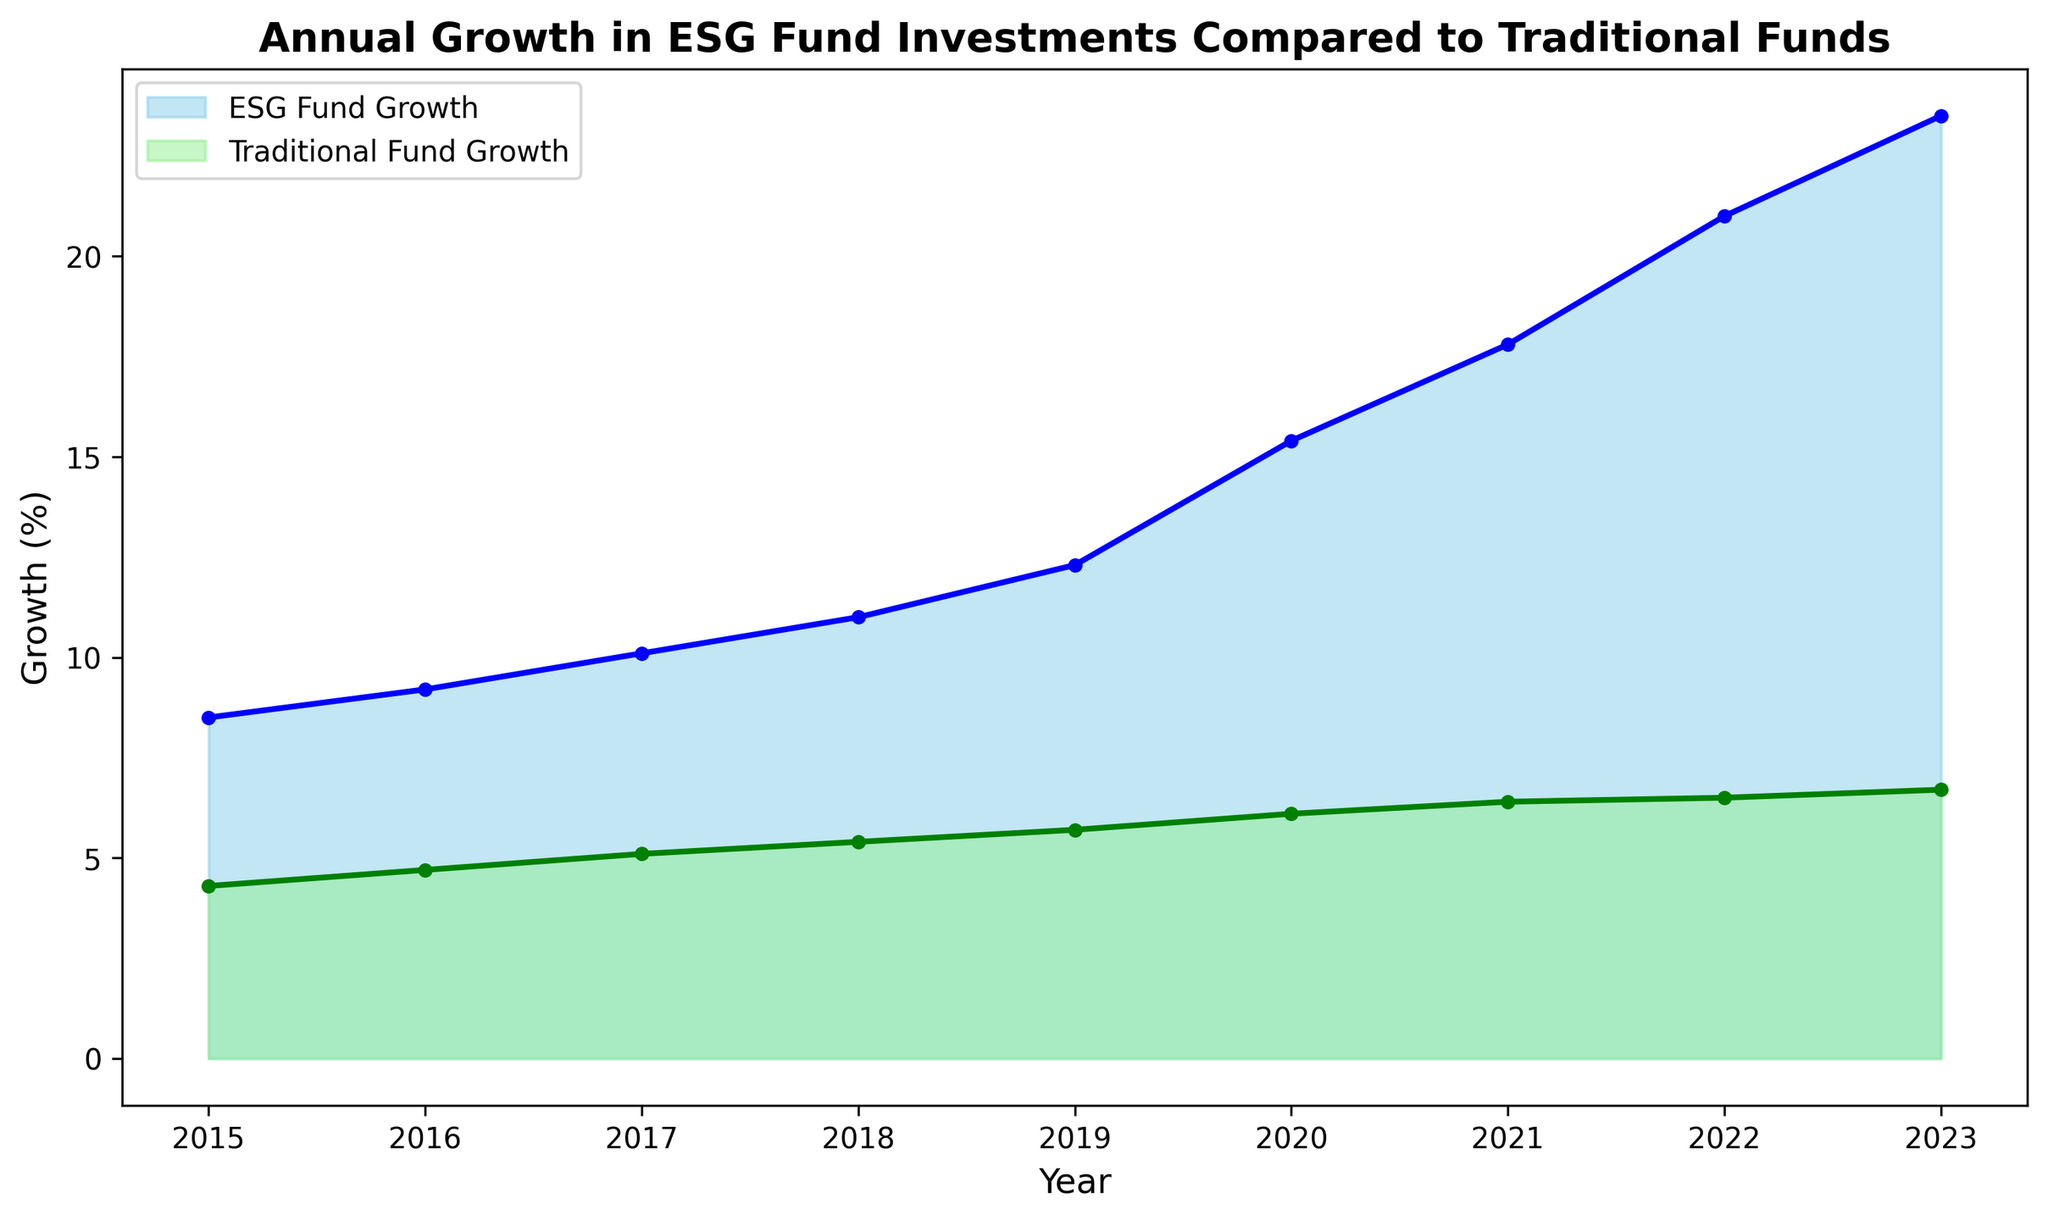What was the growth rate in ESG funds in 2023? In the area chart, the ESG Fund Growth for the year 2023 is visually represented at the topmost point on the blue shaded region. The exact value can be seen marked, which is 23.5%.
Answer: 23.5% How much higher was the ESG fund growth compared to the traditional fund growth in 2018? Look at the values for 2018. ESG Fund Growth is 11.0%, and Traditional Fund Growth is 5.4%. Take the difference between these two values: 11.0 - 5.4 = 5.6%.
Answer: 5.6% In which year did the ESG funds see the largest increase in growth rate compared to the previous year? Compare the year-over-year differences in ESG growth rates. The difference from 2020 to 2021 is the highest: 2021 (17.8%) - 2020 (15.4%) = 2.4%. Calculate similar year-over-year differences for other years to confirm.
Answer: 2021 Which year marks the first instance when the growth rate of ESG funds was more than double that of traditional funds? In 2019, ESG Fund Growth was 12.3% and Traditional Fund Growth was 5.7%. Since 12.3 is more than twice 5.7, 2019 is the year when the ESG growth rate first exceeded double that of traditional funds.
Answer: 2019 What is the average annual growth rate of ESG funds from 2015 to 2023? Sum all values for ESG Fund Growth from 2015 to 2023 and then divide by the number of years: (8.5 + 9.2 + 10.1 + 11.0 + 12.3 + 15.4 + 17.8 + 21.0 + 23.5) / 9. The total is 128.8, and the average is 128.8 / 9.
Answer: 14.3% What is the difference between the highest and lowest growth rates for traditional funds in the given period? The highest growth rate for traditional funds is 6.7% in 2023 and the lowest is 4.3% in 2015. Subtract the lowest from the highest: 6.7 - 4.3 = 2.4%.
Answer: 2.4% How did the growth rate of traditional funds change from 2015 to 2019? The growth rate of traditional funds increased from 4.3% in 2015 to 5.7% in 2019. Simply state these changes and mention that the difference is calculated as 5.7 - 4.3 = 1.4%.
Answer: Increased by 1.4% Which type of fund had continuous growth every year, and how can it be identified from the chart? Both ESG and traditional funds experienced continuous growth every year. This can be identified by observing that the plots for both funds show a consistently upward trend without any dips from one year to the next.
Answer: Both ESG and Traditional Which fund showed a greater overall growth trend from 2015 to 2023, and how is this visualized? The ESG Fund Growth shows a greater overall growth trend as it starts from 8.5% in 2015 and reaches 23.5% in 2023. This information can be visualized by the steeper slope and larger area under the blue region compared to the green region representing Traditional Fund Growth.
Answer: ESG Fund 